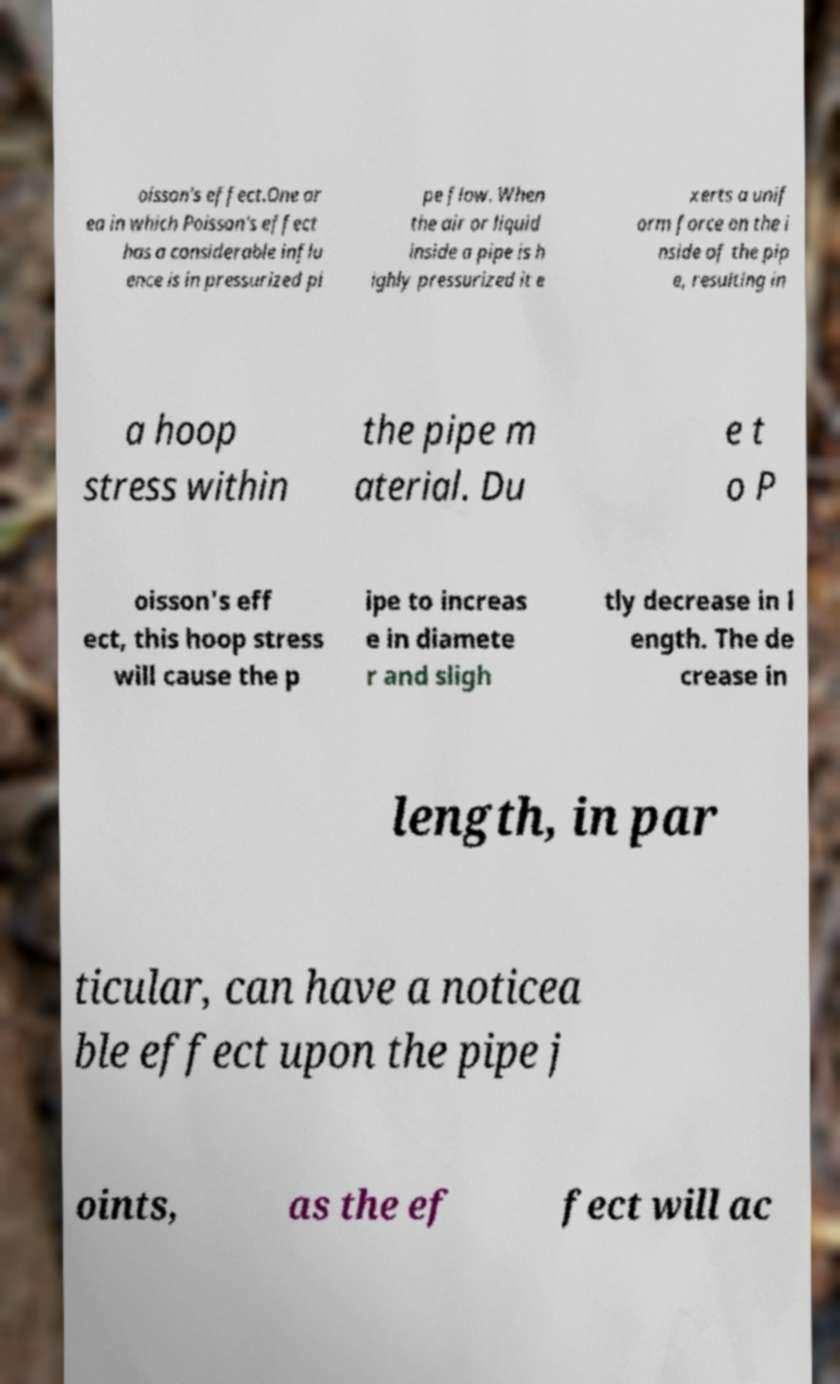Could you extract and type out the text from this image? oisson's effect.One ar ea in which Poisson's effect has a considerable influ ence is in pressurized pi pe flow. When the air or liquid inside a pipe is h ighly pressurized it e xerts a unif orm force on the i nside of the pip e, resulting in a hoop stress within the pipe m aterial. Du e t o P oisson's eff ect, this hoop stress will cause the p ipe to increas e in diamete r and sligh tly decrease in l ength. The de crease in length, in par ticular, can have a noticea ble effect upon the pipe j oints, as the ef fect will ac 